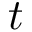Convert formula to latex. <formula><loc_0><loc_0><loc_500><loc_500>t</formula> 